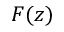Convert formula to latex. <formula><loc_0><loc_0><loc_500><loc_500>F ( z )</formula> 